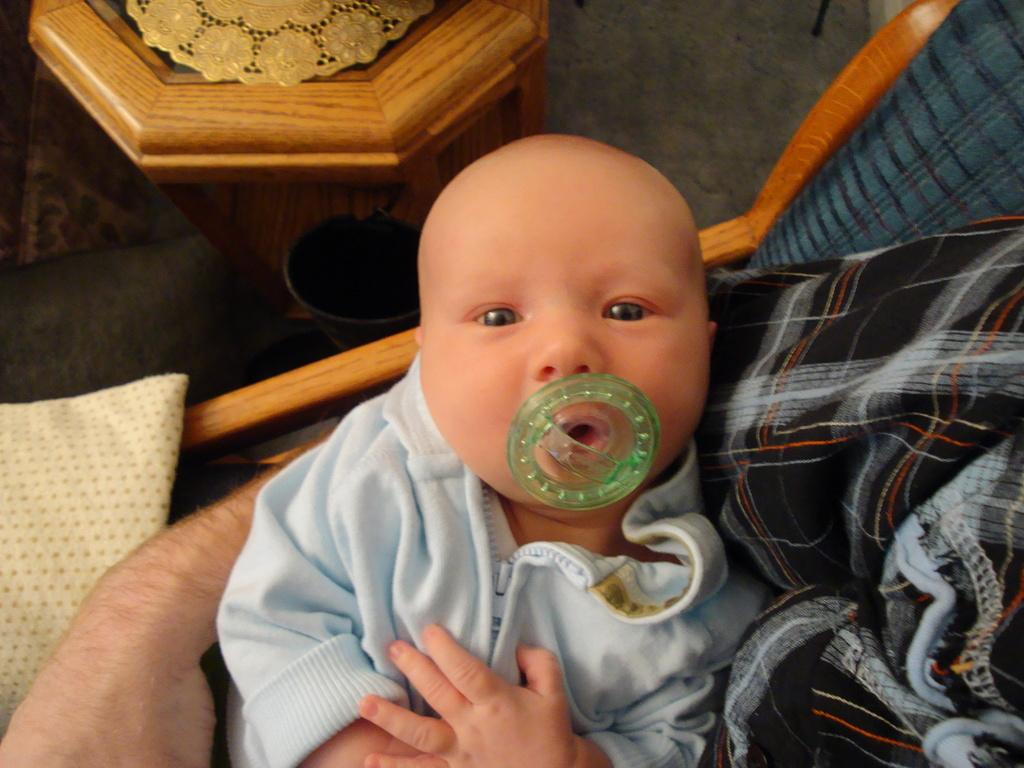What is the main subject of the image? There is a baby in the image. What is the baby doing in the image? The baby has a honey nipple in his mouth. What can be seen on the table in the image? There is a golden-colored plate on the table. Who is holding the baby in the image? A person is carrying the baby. What type of lock is present on the baby's forehead in the image? There is no lock present on the baby's forehead in the image. How many men are present in the image? There is no information about men in the image; it only shows a baby and a person carrying the baby. 